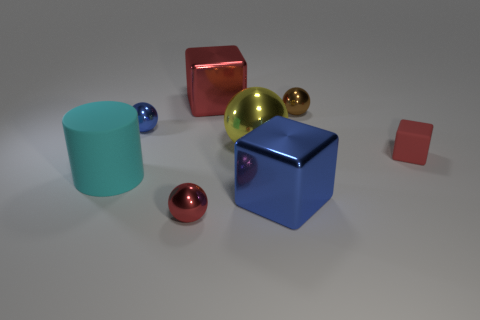Subtract 1 blocks. How many blocks are left? 2 Subtract all small balls. How many balls are left? 1 Subtract all purple spheres. Subtract all green cylinders. How many spheres are left? 4 Add 1 small brown objects. How many objects exist? 9 Subtract all cylinders. How many objects are left? 7 Subtract 0 yellow cylinders. How many objects are left? 8 Subtract all red shiny spheres. Subtract all big cyan matte objects. How many objects are left? 6 Add 3 rubber cubes. How many rubber cubes are left? 4 Add 8 big cyan things. How many big cyan things exist? 9 